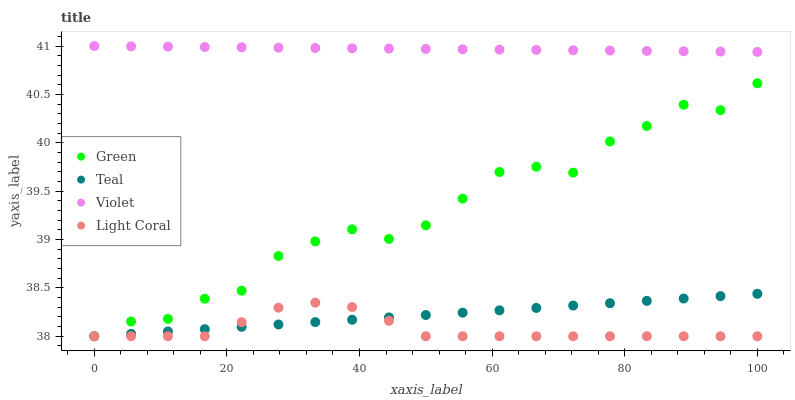Does Light Coral have the minimum area under the curve?
Answer yes or no. Yes. Does Violet have the maximum area under the curve?
Answer yes or no. Yes. Does Green have the minimum area under the curve?
Answer yes or no. No. Does Green have the maximum area under the curve?
Answer yes or no. No. Is Teal the smoothest?
Answer yes or no. Yes. Is Green the roughest?
Answer yes or no. Yes. Is Green the smoothest?
Answer yes or no. No. Is Teal the roughest?
Answer yes or no. No. Does Light Coral have the lowest value?
Answer yes or no. Yes. Does Violet have the lowest value?
Answer yes or no. No. Does Violet have the highest value?
Answer yes or no. Yes. Does Green have the highest value?
Answer yes or no. No. Is Teal less than Violet?
Answer yes or no. Yes. Is Violet greater than Teal?
Answer yes or no. Yes. Does Light Coral intersect Teal?
Answer yes or no. Yes. Is Light Coral less than Teal?
Answer yes or no. No. Is Light Coral greater than Teal?
Answer yes or no. No. Does Teal intersect Violet?
Answer yes or no. No. 